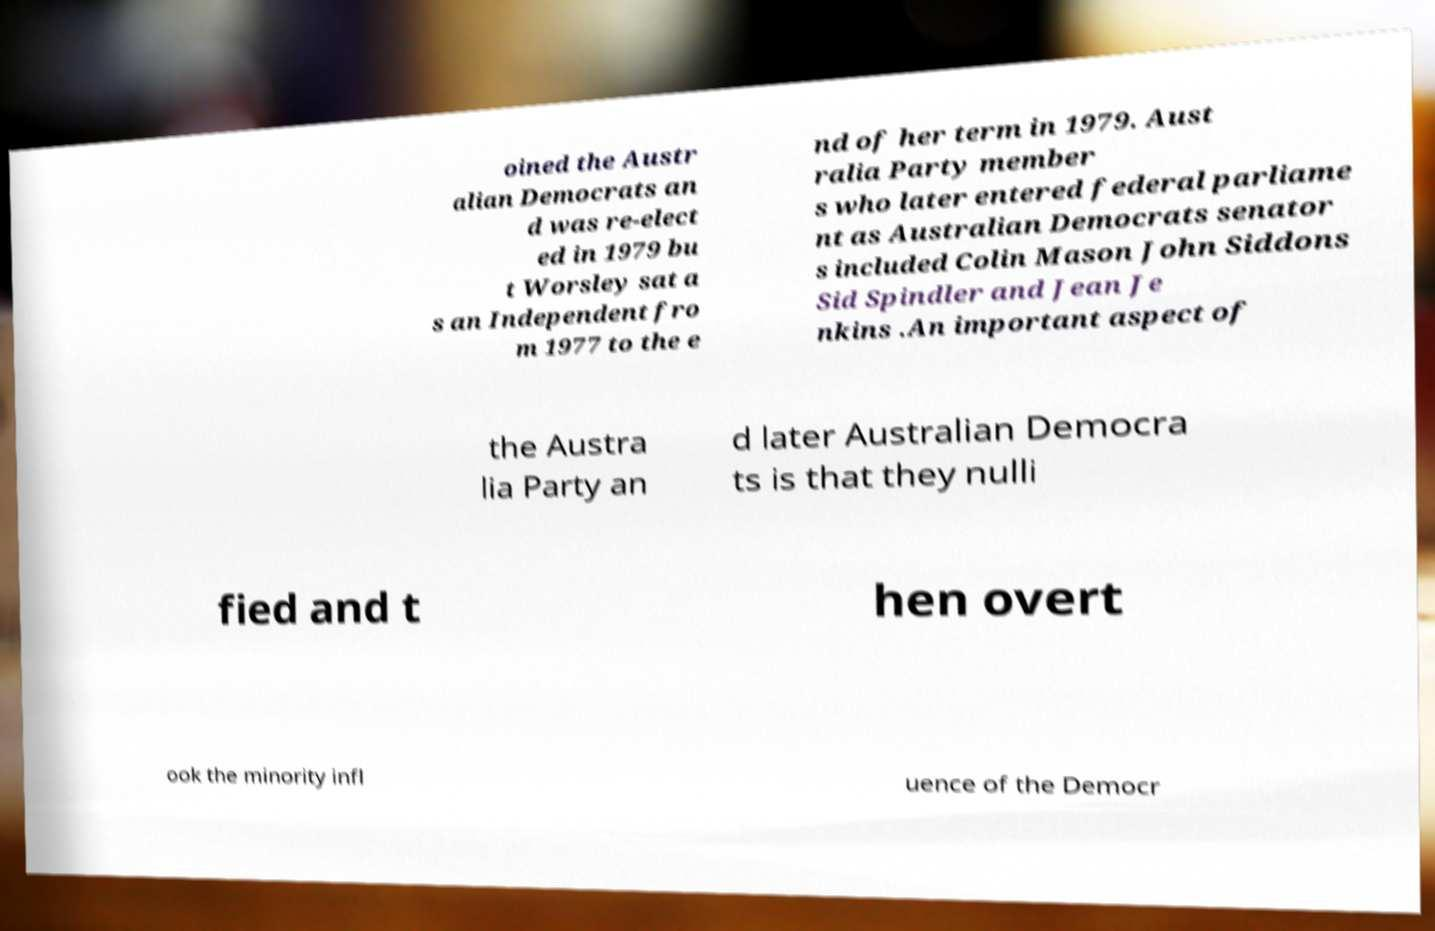There's text embedded in this image that I need extracted. Can you transcribe it verbatim? oined the Austr alian Democrats an d was re-elect ed in 1979 bu t Worsley sat a s an Independent fro m 1977 to the e nd of her term in 1979. Aust ralia Party member s who later entered federal parliame nt as Australian Democrats senator s included Colin Mason John Siddons Sid Spindler and Jean Je nkins .An important aspect of the Austra lia Party an d later Australian Democra ts is that they nulli fied and t hen overt ook the minority infl uence of the Democr 